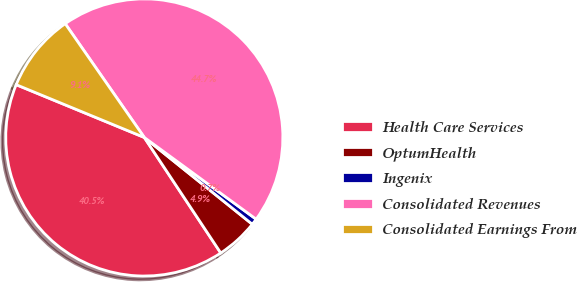Convert chart. <chart><loc_0><loc_0><loc_500><loc_500><pie_chart><fcel>Health Care Services<fcel>OptumHealth<fcel>Ingenix<fcel>Consolidated Revenues<fcel>Consolidated Earnings From<nl><fcel>40.52%<fcel>4.92%<fcel>0.73%<fcel>44.71%<fcel>9.11%<nl></chart> 